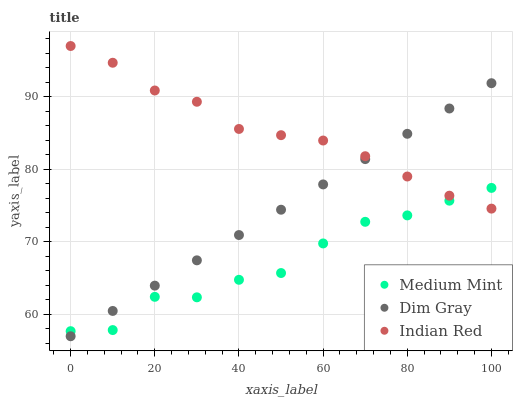Does Medium Mint have the minimum area under the curve?
Answer yes or no. Yes. Does Indian Red have the maximum area under the curve?
Answer yes or no. Yes. Does Dim Gray have the minimum area under the curve?
Answer yes or no. No. Does Dim Gray have the maximum area under the curve?
Answer yes or no. No. Is Dim Gray the smoothest?
Answer yes or no. Yes. Is Medium Mint the roughest?
Answer yes or no. Yes. Is Indian Red the smoothest?
Answer yes or no. No. Is Indian Red the roughest?
Answer yes or no. No. Does Dim Gray have the lowest value?
Answer yes or no. Yes. Does Indian Red have the lowest value?
Answer yes or no. No. Does Indian Red have the highest value?
Answer yes or no. Yes. Does Dim Gray have the highest value?
Answer yes or no. No. Does Medium Mint intersect Dim Gray?
Answer yes or no. Yes. Is Medium Mint less than Dim Gray?
Answer yes or no. No. Is Medium Mint greater than Dim Gray?
Answer yes or no. No. 